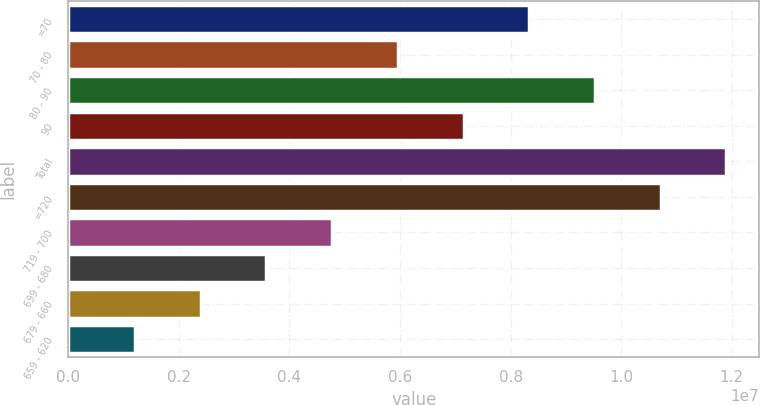Convert chart to OTSL. <chart><loc_0><loc_0><loc_500><loc_500><bar_chart><fcel>=70<fcel>70 - 80<fcel>80 - 90<fcel>90<fcel>Total<fcel>=720<fcel>719 - 700<fcel>699 - 680<fcel>679 - 660<fcel>659 - 620<nl><fcel>8.33637e+06<fcel>5.95973e+06<fcel>9.52469e+06<fcel>7.14805e+06<fcel>1.19013e+07<fcel>1.0713e+07<fcel>4.77141e+06<fcel>3.58309e+06<fcel>2.39477e+06<fcel>1.20645e+06<nl></chart> 